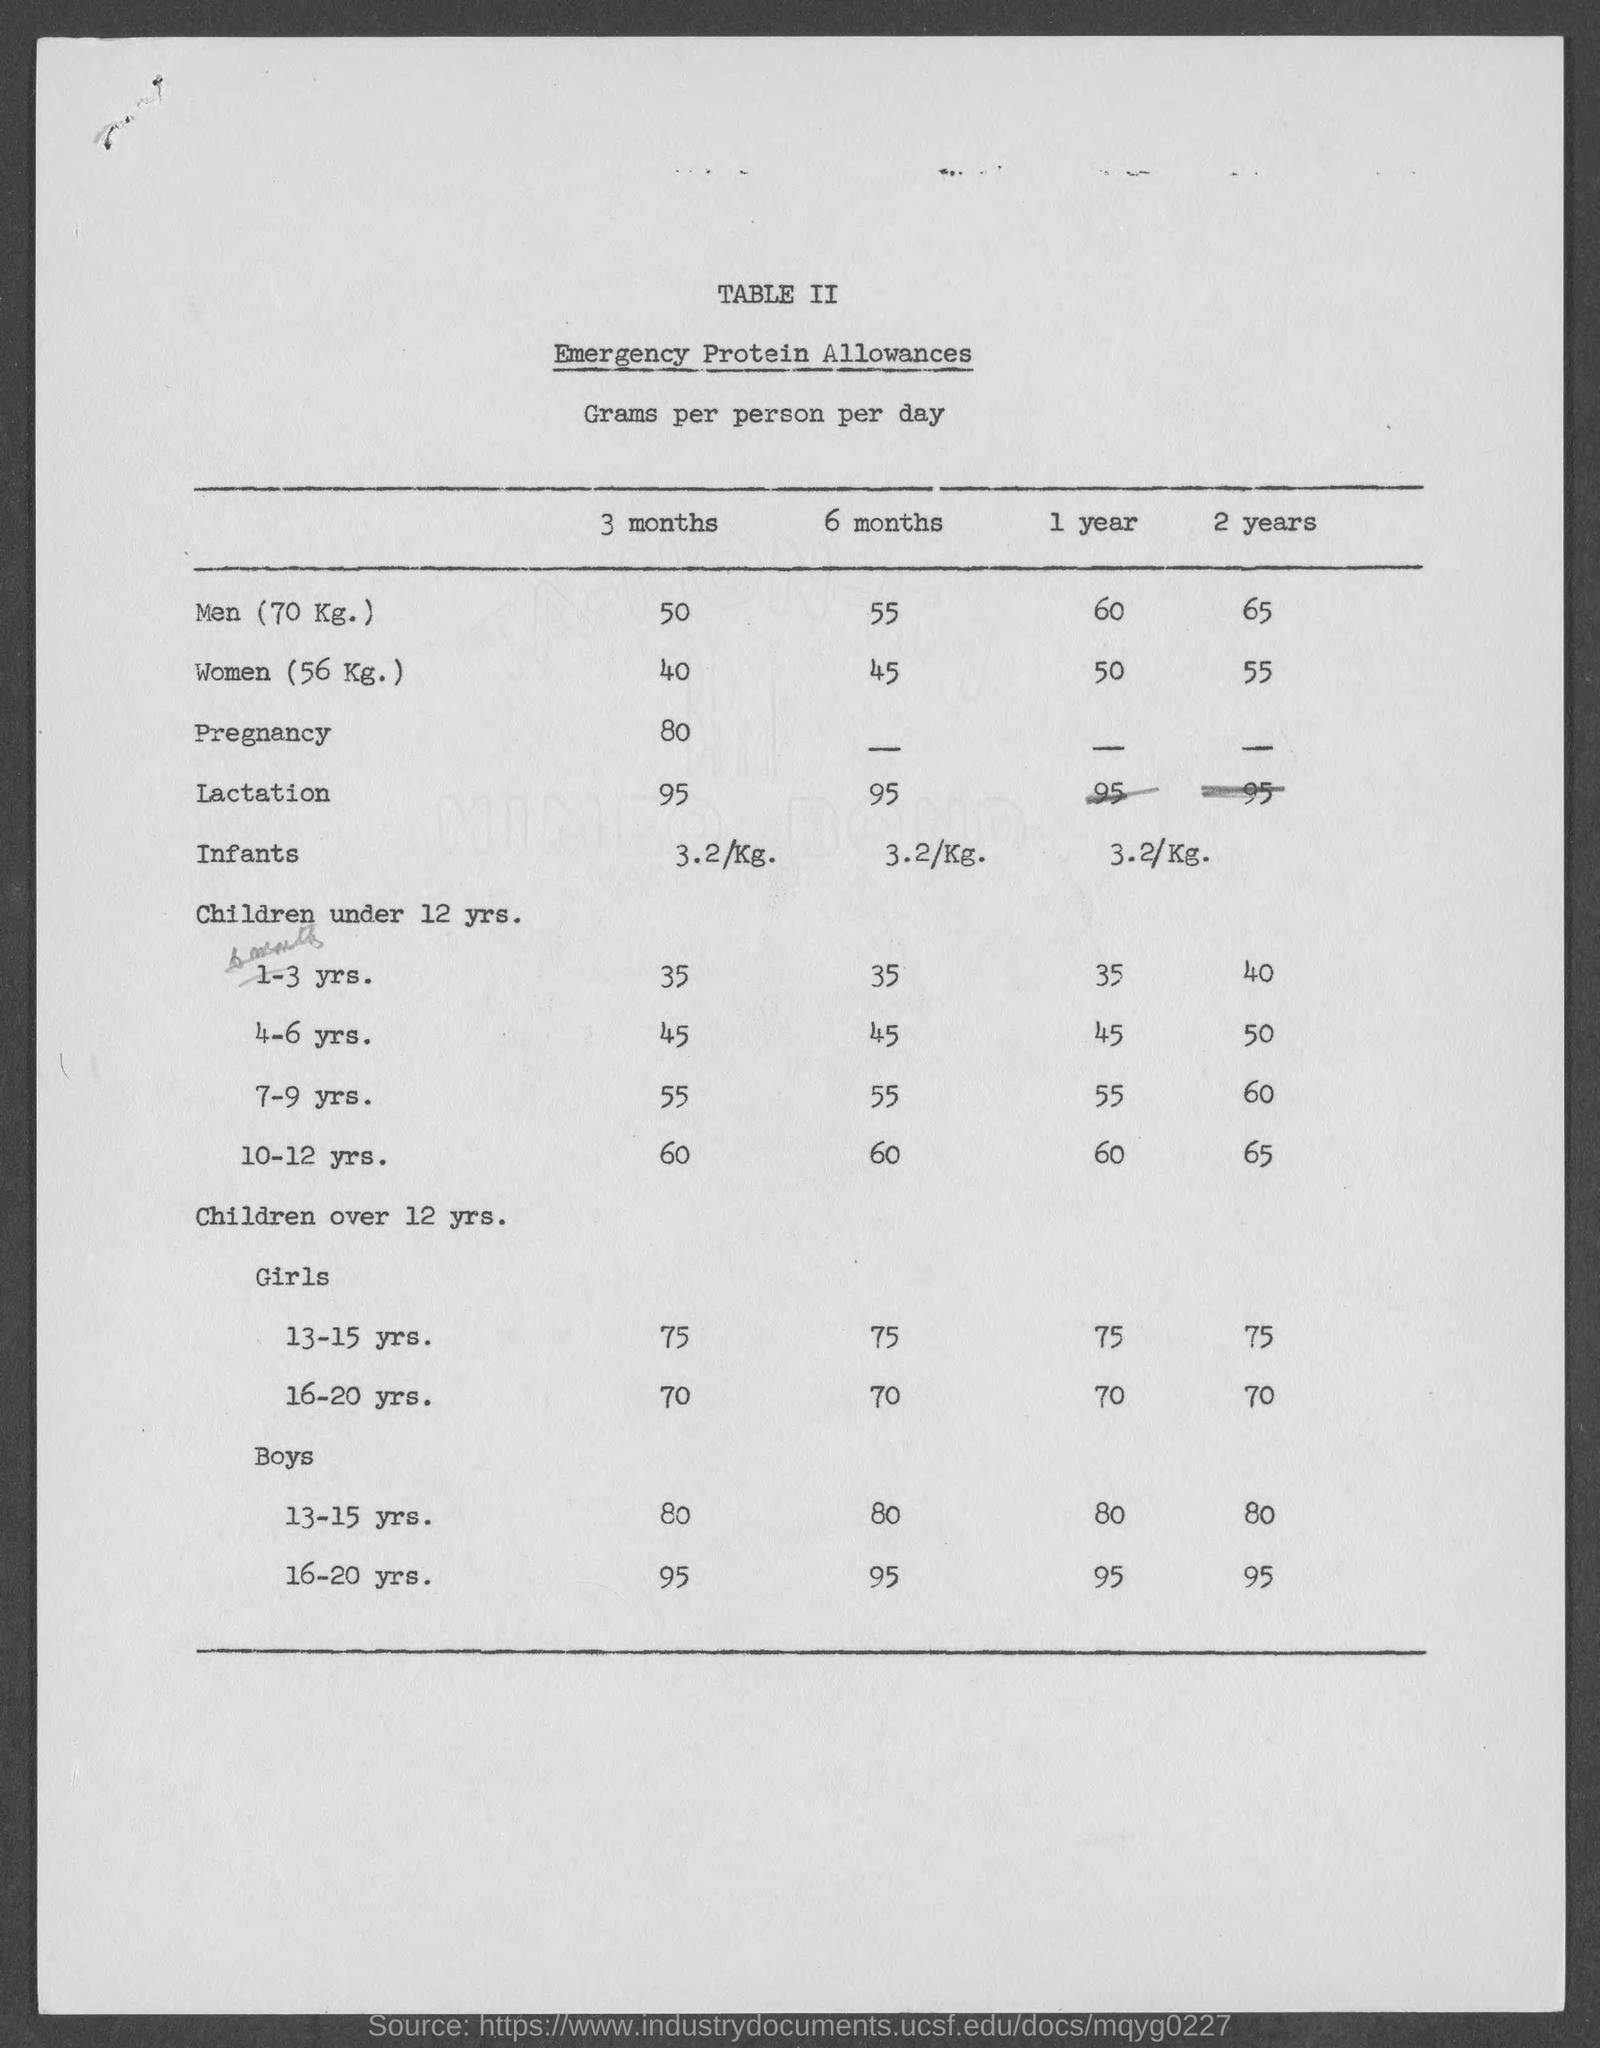Identify some key points in this picture. The title of Table II is "Emergency Protein Allowances. 